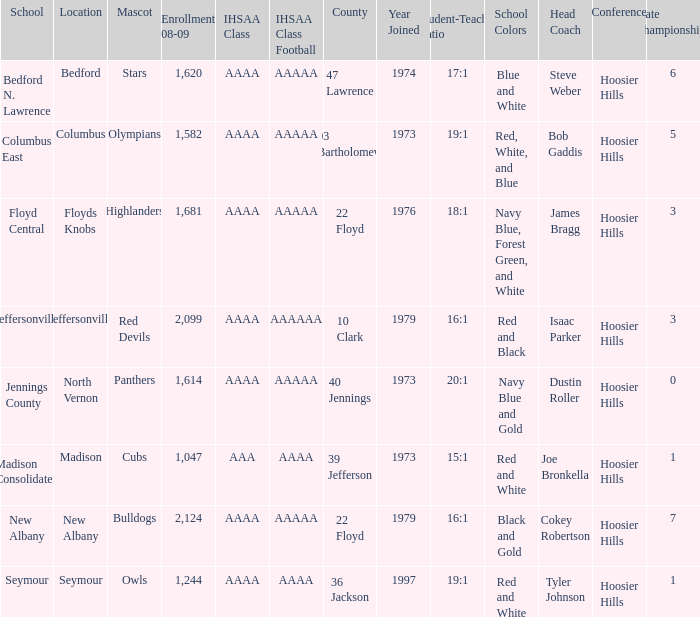What is the ihsaa class for the seymour school? AAAA. 